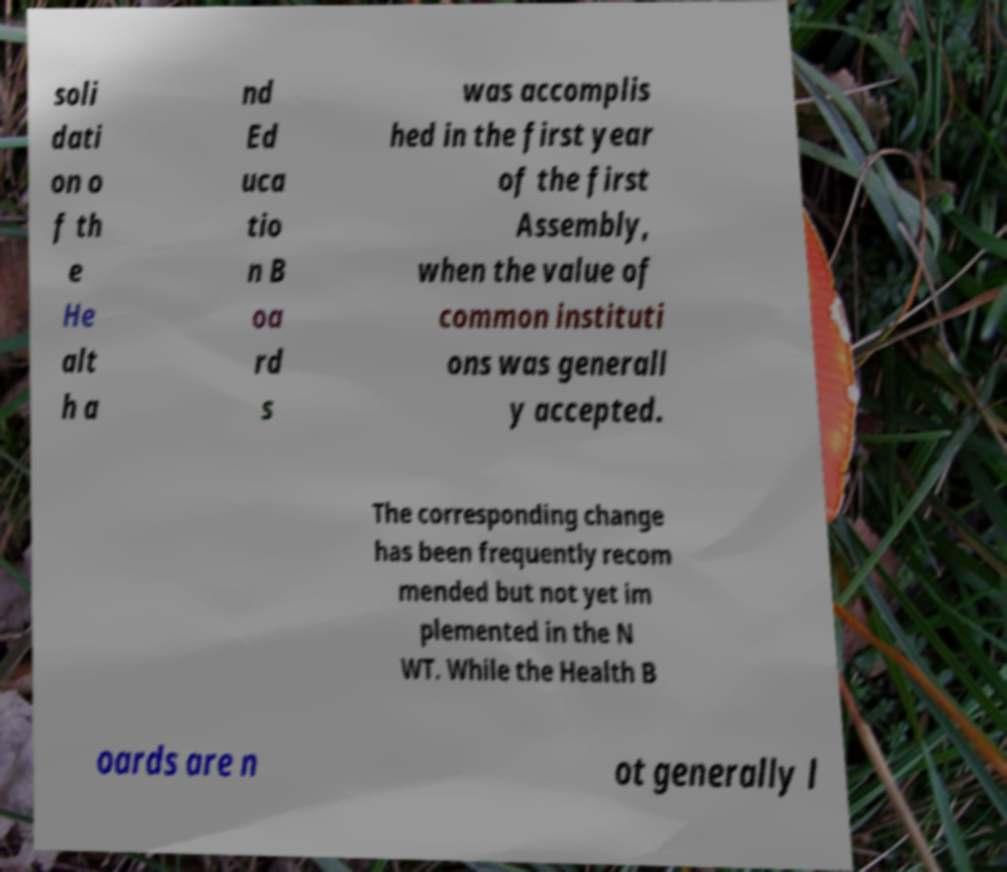I need the written content from this picture converted into text. Can you do that? soli dati on o f th e He alt h a nd Ed uca tio n B oa rd s was accomplis hed in the first year of the first Assembly, when the value of common instituti ons was generall y accepted. The corresponding change has been frequently recom mended but not yet im plemented in the N WT. While the Health B oards are n ot generally l 